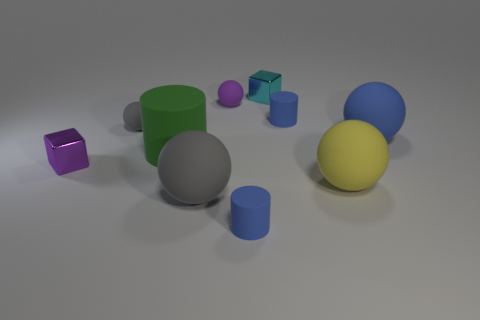Subtract all purple blocks. How many blocks are left? 1 Subtract all tiny purple spheres. How many spheres are left? 4 Subtract 1 cyan cubes. How many objects are left? 9 Subtract all blocks. How many objects are left? 8 Subtract 1 cubes. How many cubes are left? 1 Subtract all green balls. Subtract all blue cubes. How many balls are left? 5 Subtract all yellow balls. How many red blocks are left? 0 Subtract all gray cylinders. Subtract all gray objects. How many objects are left? 8 Add 2 big yellow objects. How many big yellow objects are left? 3 Add 9 tiny purple metallic cubes. How many tiny purple metallic cubes exist? 10 